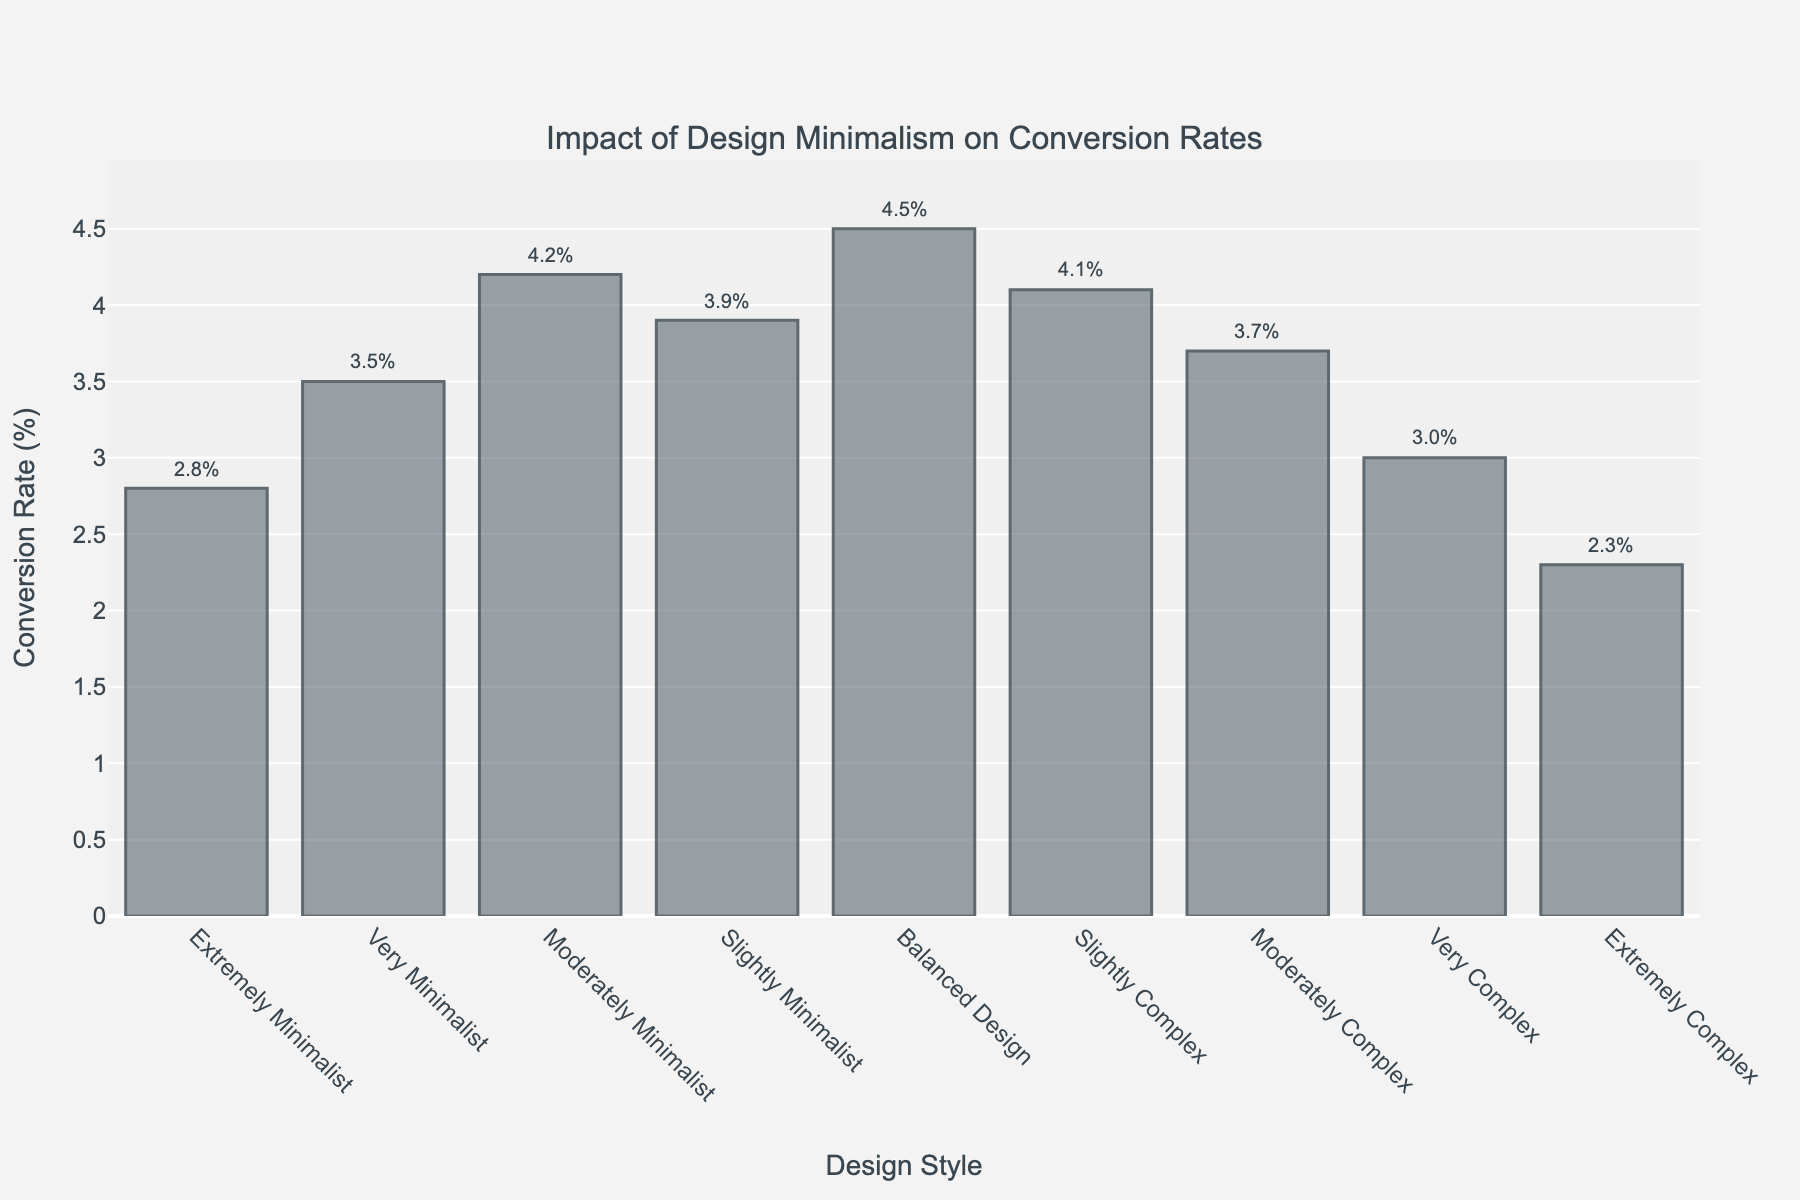Which design style has the highest conversion rate? The highest bar on the chart corresponds to the design style labeled "Balanced Design" with a conversion rate of 4.5%.
Answer: Balanced Design Which design style has the lowest conversion rate? The lowest bar on the chart corresponds to the design style labeled "Extremely Complex" with a conversion rate of 2.3%.
Answer: Extremely Complex What's the difference in conversion rate between Very Minimalist and Very Complex designs? The conversion rate of Very Minimalist design is 3.5% and that of Very Complex design is 3.0%. The difference is 3.5% - 3.0% = 0.5%.
Answer: 0.5% Which design styles have a conversion rate higher than 4%? Looking at the bars with conversion rates above 4%, the design styles are "Balanced Design" (4.5%), "Moderately Minimalist" (4.2%), and "Slightly Complex" (4.1%).
Answer: Balanced Design, Moderately Minimalist, Slightly Complex Compare the conversion rates of Extremely Minimalist and Moderately Complex designs. Which one is higher and by how much? The conversion rate of Extremely Minimalist design is 2.8% and that of Moderately Complex design is 3.7%. Moderately Complex is higher by 3.7% - 2.8% = 0.9%.
Answer: Moderately Complex by 0.9% What is the average conversion rate of all the minimalist design styles (Extremely Minimalist to Slightly Minimalist)? The conversion rates are 2.8%, 3.5%, 4.2%, and 3.9%. The average is calculated as (2.8 + 3.5 + 4.2 + 3.9) / 4 = 3.6%.
Answer: 3.6% What’s the range of conversion rates shown in the chart? The highest conversion rate is 4.5% (Balanced Design) and the lowest is 2.3% (Extremely Complex). The range is 4.5% - 2.3% = 2.2%.
Answer: 2.2% If you sum the conversion rates of the design styles labeled as complex (Slightly Complex to Extremely Complex), what is the total? Conversion rates for Slightly Complex, Moderately Complex, Very Complex, and Extremely Complex are 4.1%, 3.7%, 3.0%, and 2.3% respectively. The total is 4.1 + 3.7 + 3.0 + 2.3 = 13.1%.
Answer: 13.1% Which design styles have conversion rates within 0.5% of the Moderately Minimalist design style? The conversion rate for Moderately Minimalist is 4.2%. The styles within 0.5% are Slightly Minimalist (3.9%) and Slightly Complex (4.1%).
Answer: Slightly Minimalist, Slightly Complex 